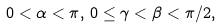Convert formula to latex. <formula><loc_0><loc_0><loc_500><loc_500>0 < \alpha < \pi , \, 0 \leq \gamma < \beta < \pi / 2 ,</formula> 